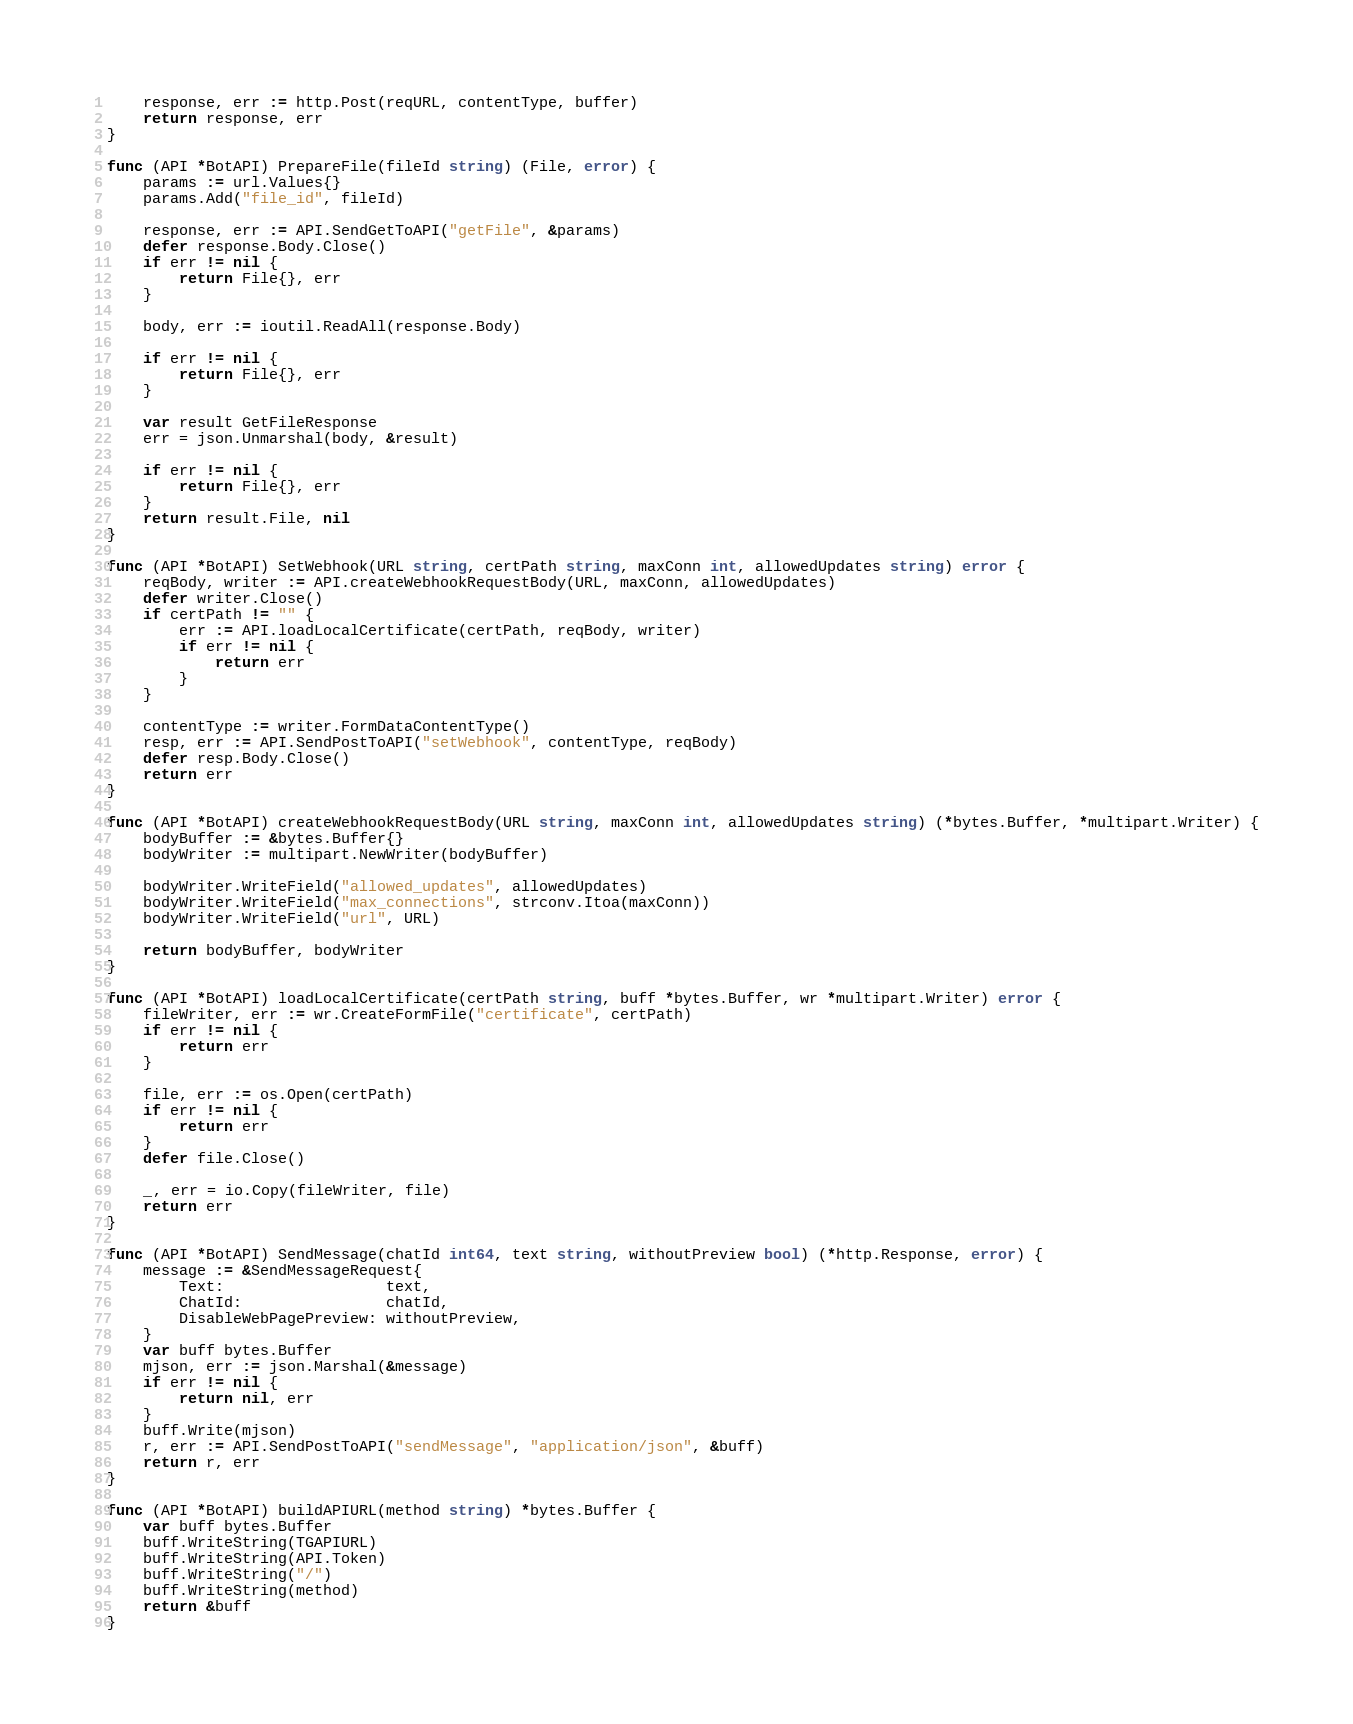<code> <loc_0><loc_0><loc_500><loc_500><_Go_>	response, err := http.Post(reqURL, contentType, buffer)
	return response, err
}

func (API *BotAPI) PrepareFile(fileId string) (File, error) {
	params := url.Values{}
	params.Add("file_id", fileId)

	response, err := API.SendGetToAPI("getFile", &params)
	defer response.Body.Close()
	if err != nil {
		return File{}, err
	}

	body, err := ioutil.ReadAll(response.Body)

	if err != nil {
		return File{}, err
	}

	var result GetFileResponse
	err = json.Unmarshal(body, &result)

	if err != nil {
		return File{}, err
	}
	return result.File, nil
}

func (API *BotAPI) SetWebhook(URL string, certPath string, maxConn int, allowedUpdates string) error {
	reqBody, writer := API.createWebhookRequestBody(URL, maxConn, allowedUpdates)
	defer writer.Close()
	if certPath != "" {
		err := API.loadLocalCertificate(certPath, reqBody, writer)
		if err != nil {
			return err
		}
	}

	contentType := writer.FormDataContentType()
	resp, err := API.SendPostToAPI("setWebhook", contentType, reqBody)
	defer resp.Body.Close()
	return err
}

func (API *BotAPI) createWebhookRequestBody(URL string, maxConn int, allowedUpdates string) (*bytes.Buffer, *multipart.Writer) {
	bodyBuffer := &bytes.Buffer{}
	bodyWriter := multipart.NewWriter(bodyBuffer)

	bodyWriter.WriteField("allowed_updates", allowedUpdates)
	bodyWriter.WriteField("max_connections", strconv.Itoa(maxConn))
	bodyWriter.WriteField("url", URL)

	return bodyBuffer, bodyWriter
}

func (API *BotAPI) loadLocalCertificate(certPath string, buff *bytes.Buffer, wr *multipart.Writer) error {
	fileWriter, err := wr.CreateFormFile("certificate", certPath)
	if err != nil {
		return err
	}

	file, err := os.Open(certPath)
	if err != nil {
		return err
	}
	defer file.Close()

	_, err = io.Copy(fileWriter, file)
	return err
}

func (API *BotAPI) SendMessage(chatId int64, text string, withoutPreview bool) (*http.Response, error) {
	message := &SendMessageRequest{
		Text:                  text,
		ChatId:                chatId,
		DisableWebPagePreview: withoutPreview,
	}
	var buff bytes.Buffer
	mjson, err := json.Marshal(&message)
	if err != nil {
		return nil, err
	}
	buff.Write(mjson)
	r, err := API.SendPostToAPI("sendMessage", "application/json", &buff)
	return r, err
}

func (API *BotAPI) buildAPIURL(method string) *bytes.Buffer {
	var buff bytes.Buffer
	buff.WriteString(TGAPIURL)
	buff.WriteString(API.Token)
	buff.WriteString("/")
	buff.WriteString(method)
	return &buff
}
</code> 